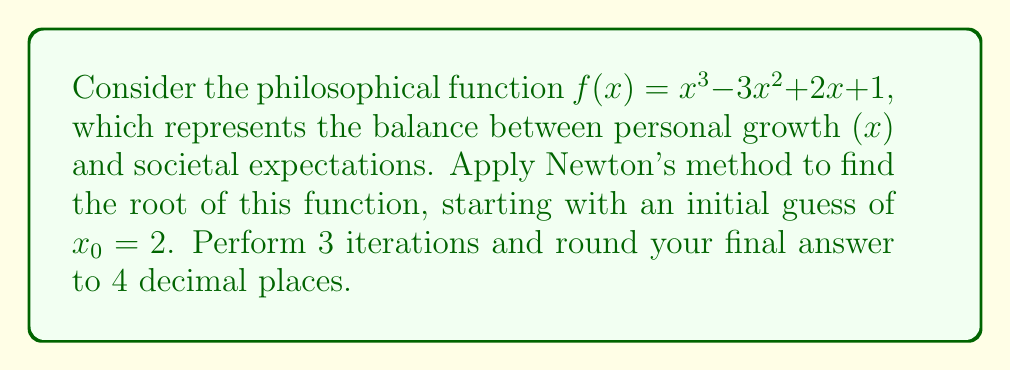Give your solution to this math problem. Newton's method is given by the formula:

$$x_{n+1} = x_n - \frac{f(x_n)}{f'(x_n)}$$

First, we need to find $f'(x)$:
$f'(x) = 3x^2 - 6x + 2$

Now, let's perform 3 iterations:

Iteration 1:
$x_0 = 2$
$f(x_0) = 2^3 - 3(2^2) + 2(2) + 1 = 8 - 12 + 4 + 1 = 1$
$f'(x_0) = 3(2^2) - 6(2) + 2 = 12 - 12 + 2 = 2$

$$x_1 = 2 - \frac{1}{2} = 1.5$$

Iteration 2:
$x_1 = 1.5$
$f(x_1) = 1.5^3 - 3(1.5^2) + 2(1.5) + 1 = 3.375 - 6.75 + 3 + 1 = 0.625$
$f'(x_1) = 3(1.5^2) - 6(1.5) + 2 = 6.75 - 9 + 2 = -0.25$

$$x_2 = 1.5 - \frac{0.625}{-0.25} = 1.5 + 2.5 = 4$$

Iteration 3:
$x_2 = 4$
$f(x_2) = 4^3 - 3(4^2) + 2(4) + 1 = 64 - 48 + 8 + 1 = 25$
$f'(x_2) = 3(4^2) - 6(4) + 2 = 48 - 24 + 2 = 26$

$$x_3 = 4 - \frac{25}{26} \approx 3.0385$$

Rounding to 4 decimal places: 3.0385
Answer: 3.0385 